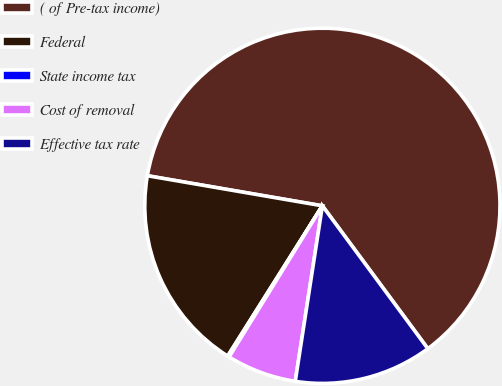<chart> <loc_0><loc_0><loc_500><loc_500><pie_chart><fcel>( of Pre-tax income)<fcel>Federal<fcel>State income tax<fcel>Cost of removal<fcel>Effective tax rate<nl><fcel>62.17%<fcel>18.76%<fcel>0.15%<fcel>6.36%<fcel>12.56%<nl></chart> 